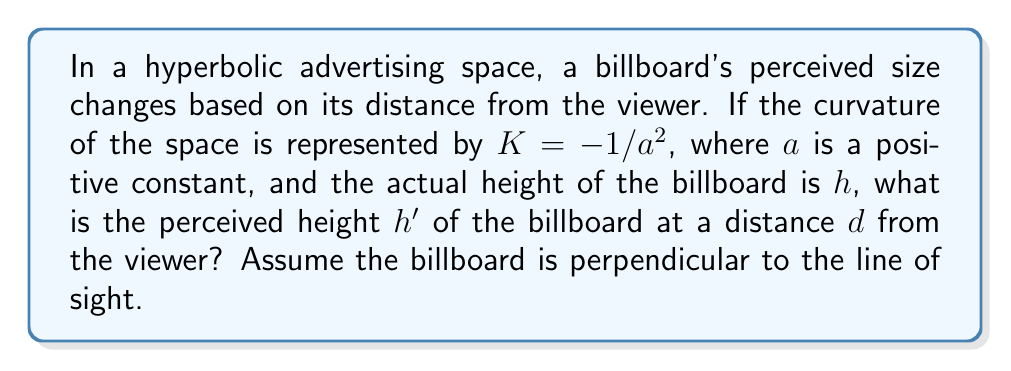What is the answer to this math problem? To solve this problem, we'll use concepts from hyperbolic geometry and visual perception:

1) In hyperbolic space, the perceived size of an object decreases exponentially with distance.

2) The formula for the perceived height $h'$ in terms of the actual height $h$, distance $d$, and curvature $K$ is:

   $$h' = h \cdot e^{\sqrt{-K} \cdot d}$$

3) We're given that $K = -1/a^2$, so let's substitute this:

   $$h' = h \cdot e^{\sqrt{1/a^2} \cdot d}$$

4) Simplify the square root:

   $$h' = h \cdot e^{d/a}$$

5) This formula gives us the perceived height $h'$ of the billboard at a distance $d$ in a hyperbolic space with curvature $K = -1/a^2$.

6) Note that as $d$ increases, $e^{d/a}$ decreases, making the perceived height smaller, which aligns with our intuition about objects appearing smaller at greater distances in hyperbolic space.

7) This exponential decrease in perceived size with distance is more rapid than in Euclidean space, where the decrease is linear. This could have interesting implications for advertising, as it might affect how quickly billboards become unreadable or lose impact as viewers move away.
Answer: $h' = h \cdot e^{d/a}$ 